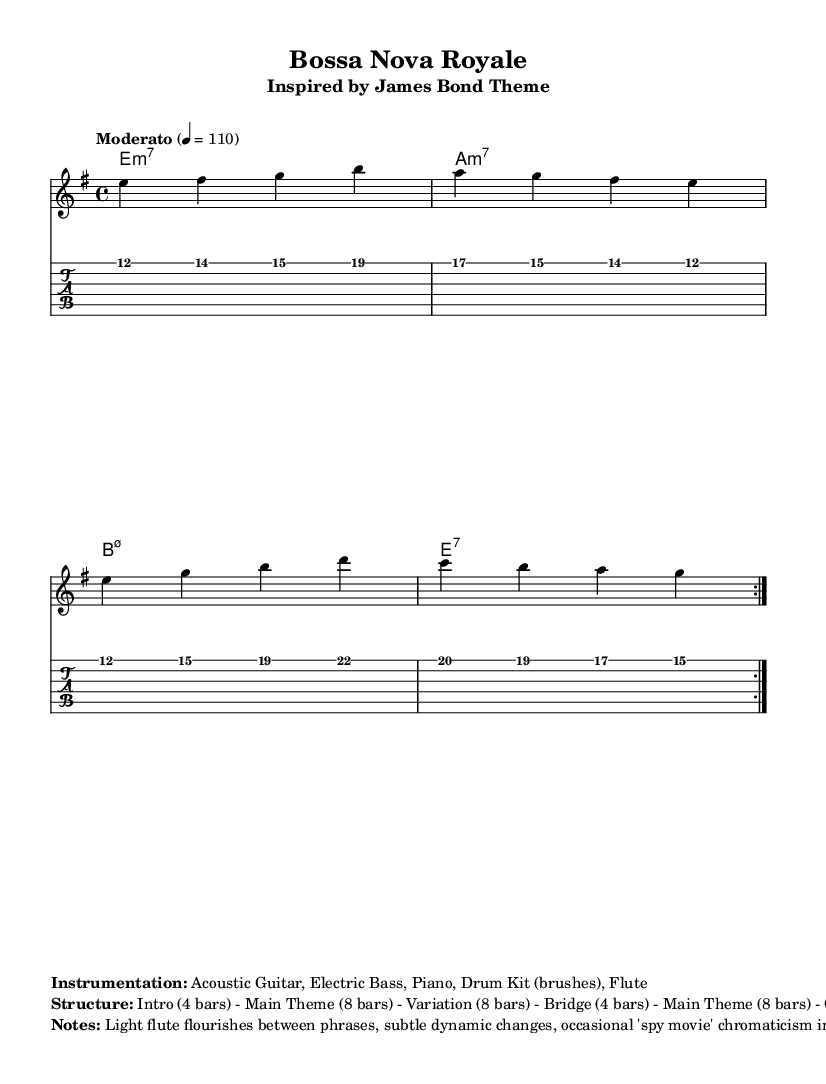What is the key signature of this music? The music is in E minor, which has one sharp (F#) in its key signature. You can identify the key signature by looking at the left side of the staff where accidentals and sharps are indicated.
Answer: E minor What is the time signature of this sheet music? The time signature is 4/4, which means there are four beats per measure, and the quarter note gets one beat. This can be found at the beginning of the score, indicated by the time signature symbol.
Answer: 4/4 What is the tempo marking provided in the sheet music? The tempo marking is "Moderato" with a beat of 110, which indicates a moderate pace. This information is typically placed at the beginning of the score right after the clef and key signature.
Answer: Moderato 4 = 110 How many bars are in the Main Theme section? The Main Theme section consists of 8 bars, as stated in the structural notes that describe the piece. This can be confirmed by counting the measures in the highlighted Main Theme part of the score.
Answer: 8 bars What instruments are used in this arrangement? The instrumentation includes Acoustic Guitar, Electric Bass, Piano, Drum Kit (brushes), and Flute. This information is provided in the markup section, which outlines the characteristics of the musical arrangement.
Answer: Acoustic Guitar, Electric Bass, Piano, Drum Kit (brushes), Flute What type of musical flourishes are mentioned to be present in the performance? The notes mention "light flute flourishes," indicating subtle embellishments performed by the flute throughout the piece. This detail is mentioned in the notes section of the markup, emphasizing the style of performance.
Answer: Light flute flourishes What is the structure of the piece as indicated in the markup? The structure is defined as Intro (4 bars) - Main Theme (8 bars) - Variation (8 bars) - Bridge (4 bars) - Main Theme (8 bars) - Outro (4 bars). This structure is explicitly outlined in the markup of the sheet music, allowing for a clear understanding of the song's layout.
Answer: Intro (4 bars) - Main Theme (8 bars) - Variation (8 bars) - Bridge (4 bars) - Main Theme (8 bars) - Outro (4 bars) 